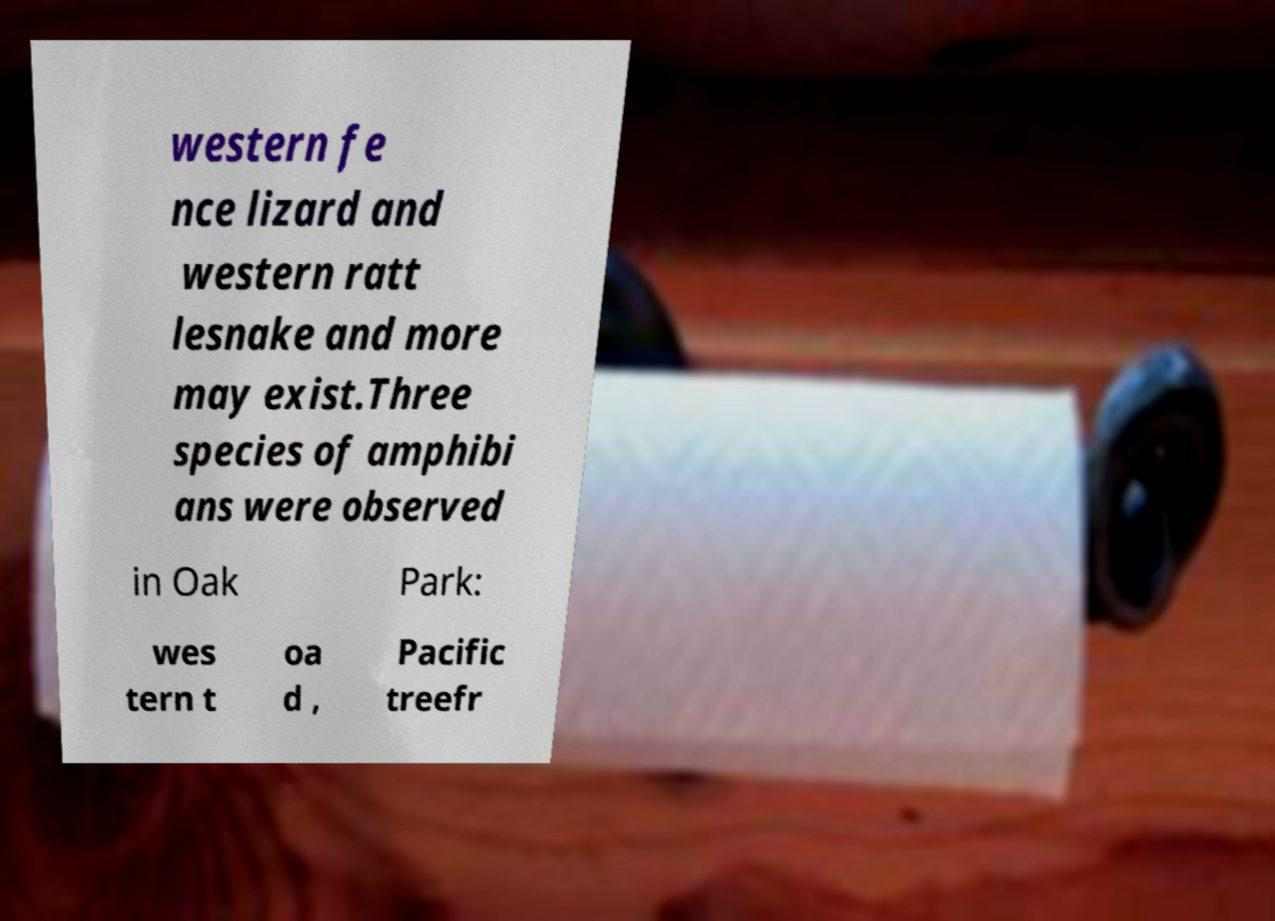Please read and relay the text visible in this image. What does it say? western fe nce lizard and western ratt lesnake and more may exist.Three species of amphibi ans were observed in Oak Park: wes tern t oa d , Pacific treefr 